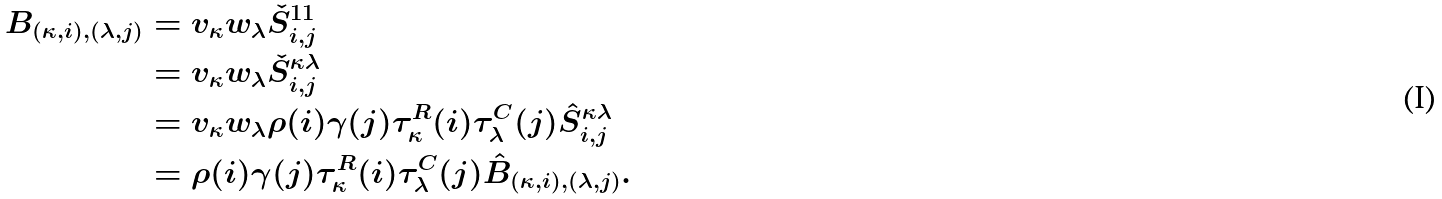<formula> <loc_0><loc_0><loc_500><loc_500>B _ { ( \kappa , i ) , ( \lambda , j ) } & = v _ { \kappa } w _ { \lambda } { \check { S } ^ { 1 1 } } _ { i , j } \\ & = v _ { \kappa } w _ { \lambda } { \check { S } ^ { \kappa \lambda } } _ { i , j } \\ & = v _ { \kappa } w _ { \lambda } \rho ( i ) \gamma ( j ) \tau ^ { R } _ { \kappa } ( i ) \tau ^ { C } _ { \lambda } ( j ) \hat { S } ^ { \kappa \lambda } _ { i , j } \\ & = \rho ( i ) \gamma ( j ) \tau ^ { R } _ { \kappa } ( i ) \tau ^ { C } _ { \lambda } ( j ) \hat { B } _ { ( \kappa , i ) , ( \lambda , j ) } .</formula> 